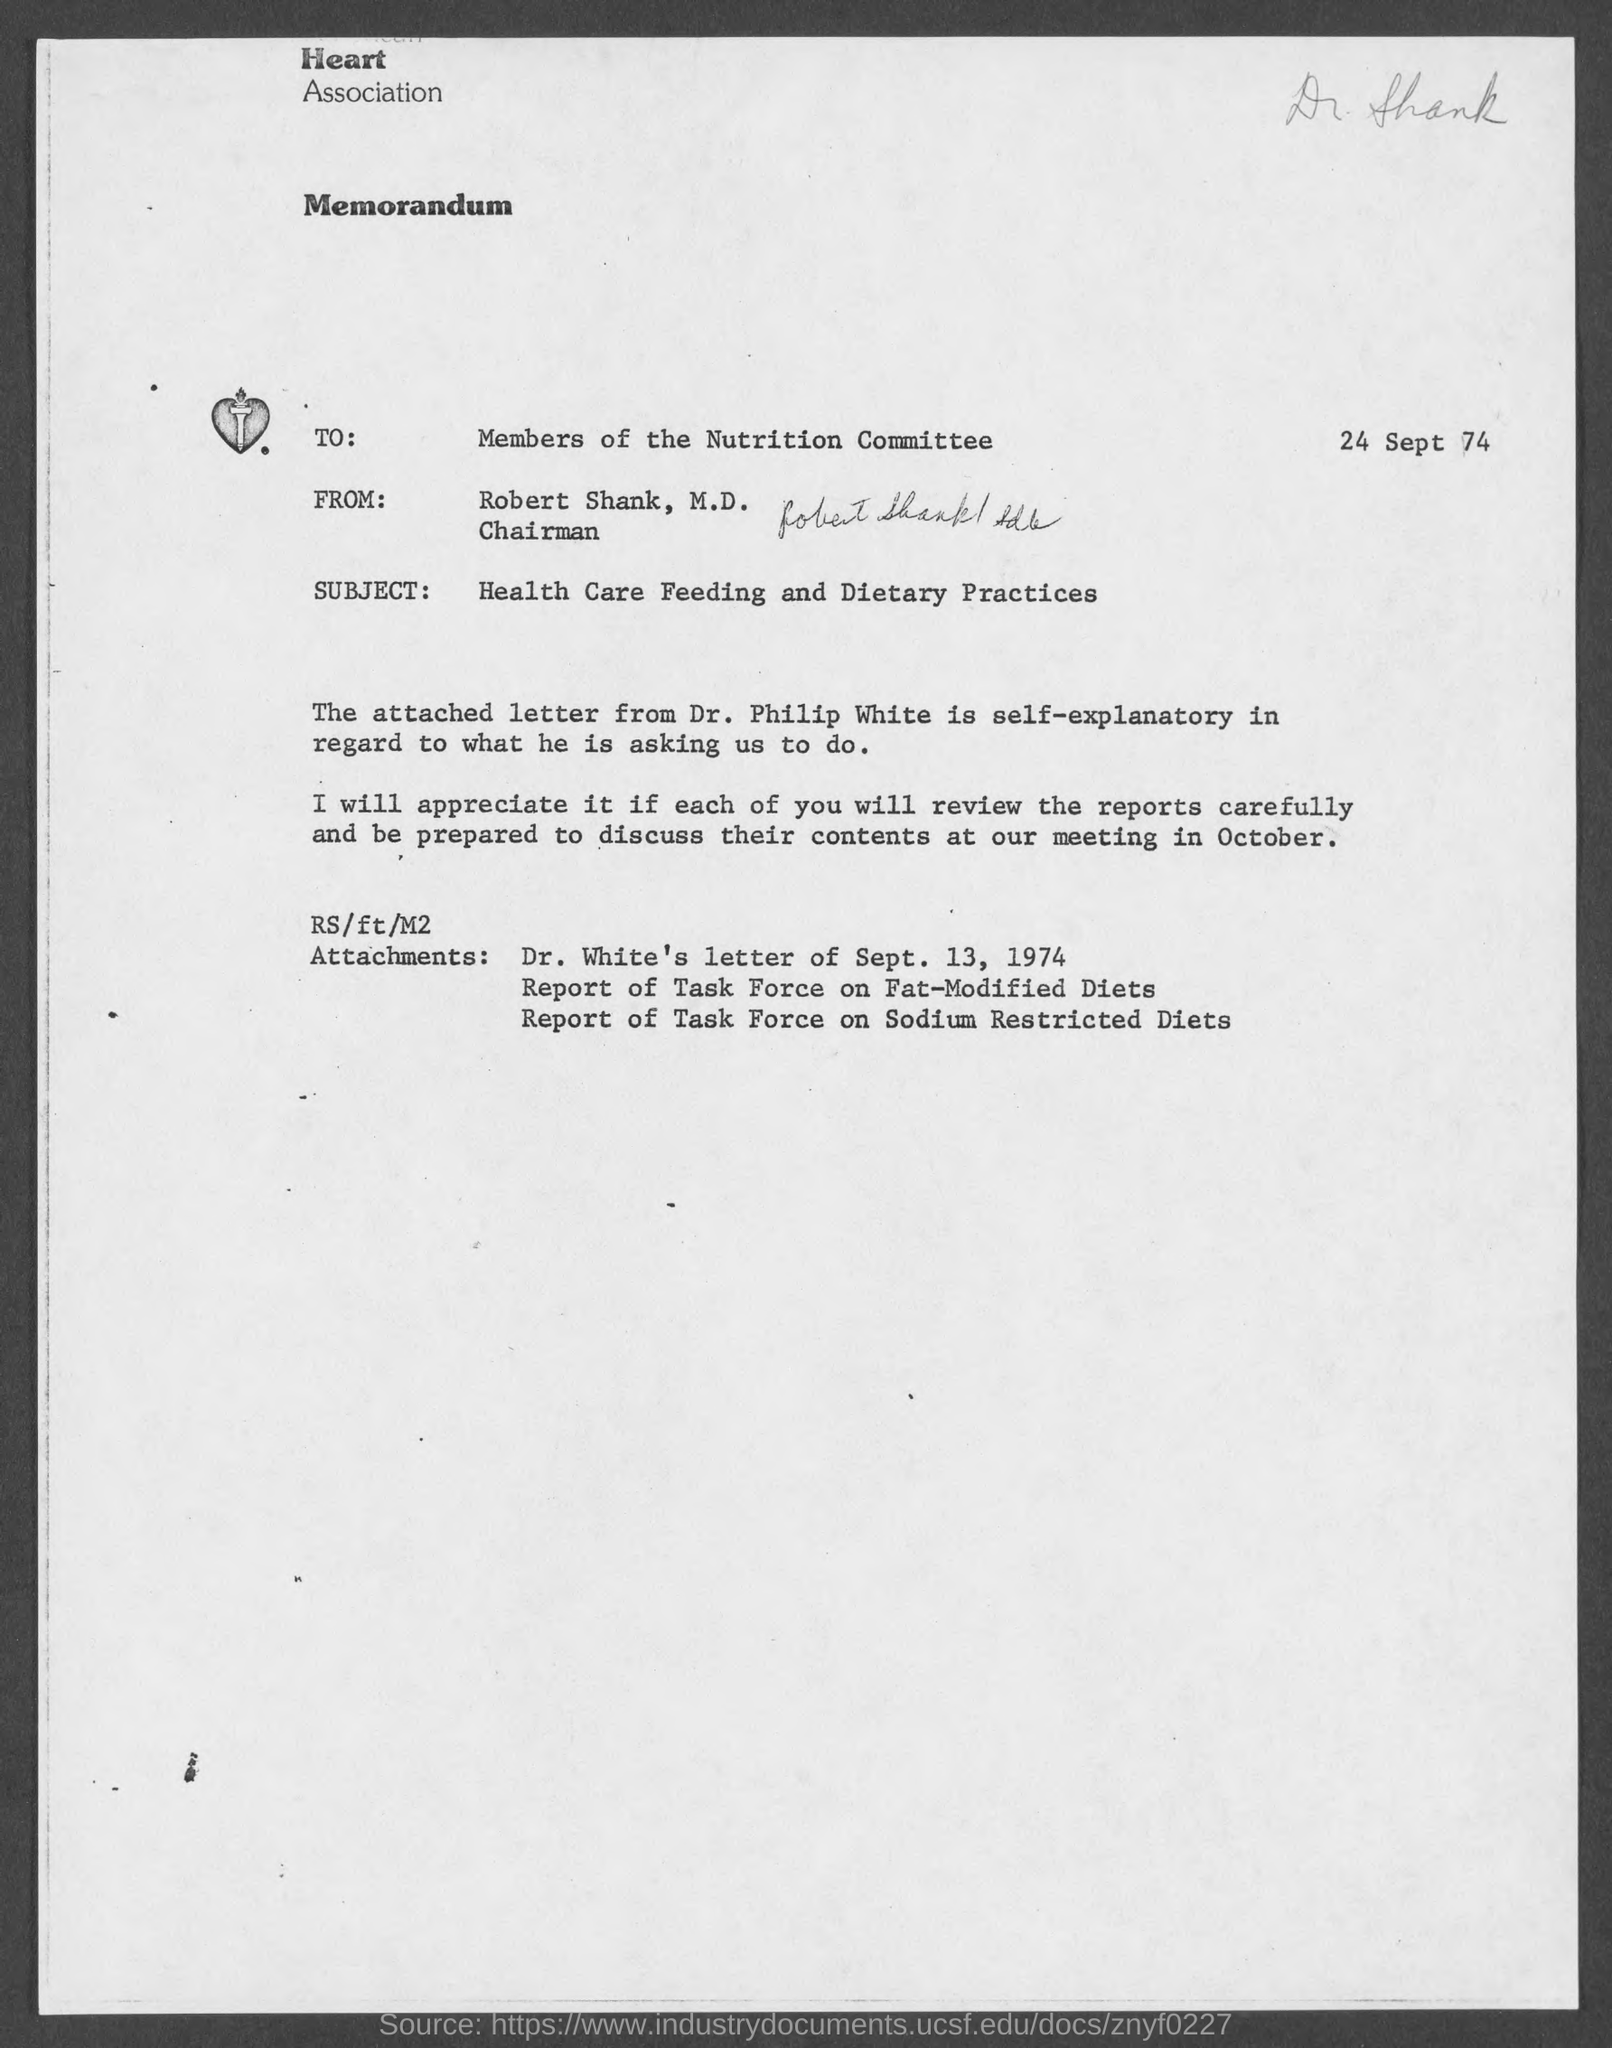Specify some key components in this picture. The subject of the memorandum is health care feeding and dietary practices. The memorandum is addressed to the members of the Nutrition Committee. This memorandum is from Robert Shank, M.D. Robert Shank, M.D. is the chairman. The memorandum is dated September 24, 1974. 